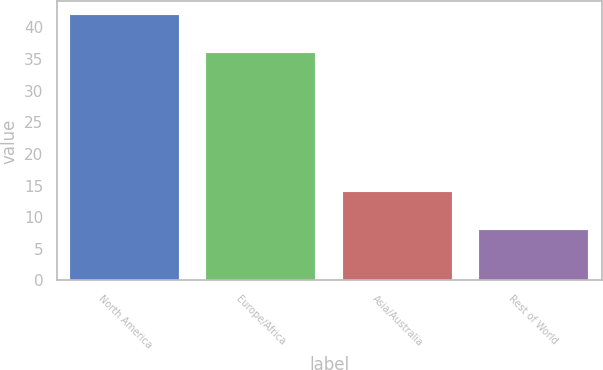<chart> <loc_0><loc_0><loc_500><loc_500><bar_chart><fcel>North America<fcel>Europe/Africa<fcel>Asia/Australia<fcel>Rest of World<nl><fcel>42<fcel>36<fcel>14<fcel>8<nl></chart> 